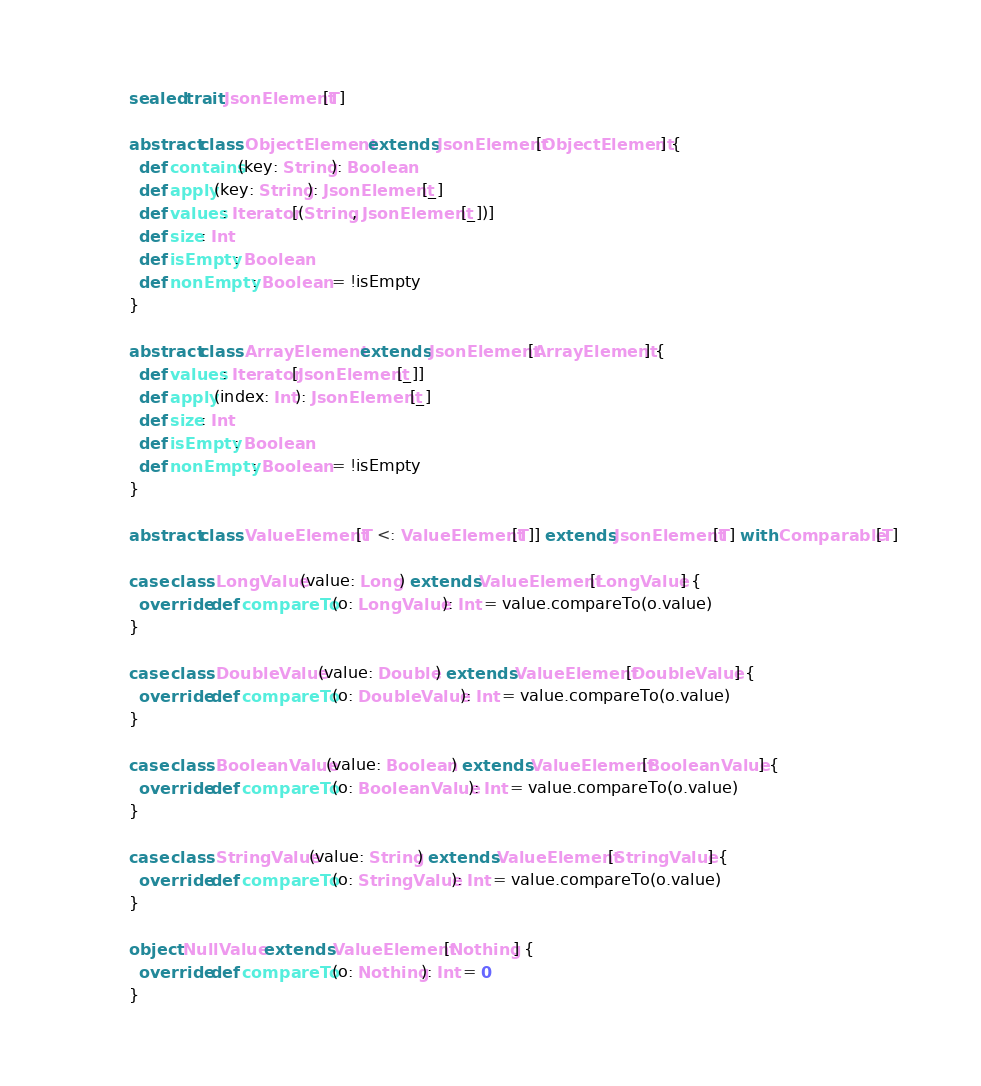Convert code to text. <code><loc_0><loc_0><loc_500><loc_500><_Scala_>sealed trait JsonElement[T]

abstract class ObjectElement extends JsonElement[ObjectElement] {
  def contains(key: String): Boolean
  def apply(key: String): JsonElement[_]
  def values: Iterator[(String, JsonElement[_])]
  def size: Int
  def isEmpty: Boolean
  def nonEmpty: Boolean = !isEmpty
}

abstract class ArrayElement extends JsonElement[ArrayElement] {
  def values: Iterator[JsonElement[_]]
  def apply(index: Int): JsonElement[_]
  def size: Int
  def isEmpty: Boolean
  def nonEmpty: Boolean = !isEmpty
}

abstract class ValueElement[T <: ValueElement[T]] extends JsonElement[T] with Comparable[T]

case class LongValue(value: Long) extends ValueElement[LongValue] {
  override def compareTo(o: LongValue): Int = value.compareTo(o.value)
}

case class DoubleValue(value: Double) extends ValueElement[DoubleValue] {
  override def compareTo(o: DoubleValue): Int = value.compareTo(o.value)
}

case class BooleanValue(value: Boolean) extends ValueElement[BooleanValue] {
  override def compareTo(o: BooleanValue): Int = value.compareTo(o.value)
}

case class StringValue(value: String) extends ValueElement[StringValue] {
  override def compareTo(o: StringValue): Int = value.compareTo(o.value)
}

object NullValue extends ValueElement[Nothing] {
  override def compareTo(o: Nothing): Int = 0
}
</code> 